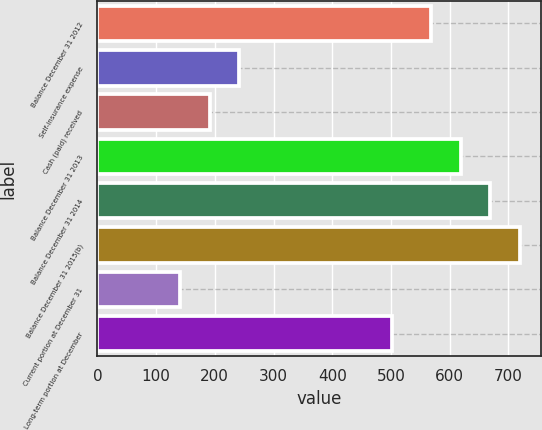<chart> <loc_0><loc_0><loc_500><loc_500><bar_chart><fcel>Balance December 31 2012<fcel>Self-insurance expense<fcel>Cash (paid) received<fcel>Balance December 31 2013<fcel>Balance December 31 2014<fcel>Balance December 31 2015(b)<fcel>Current portion at December 31<fcel>Long-term portion at December<nl><fcel>569<fcel>241.4<fcel>191.2<fcel>619.2<fcel>669.4<fcel>719.6<fcel>141<fcel>502<nl></chart> 